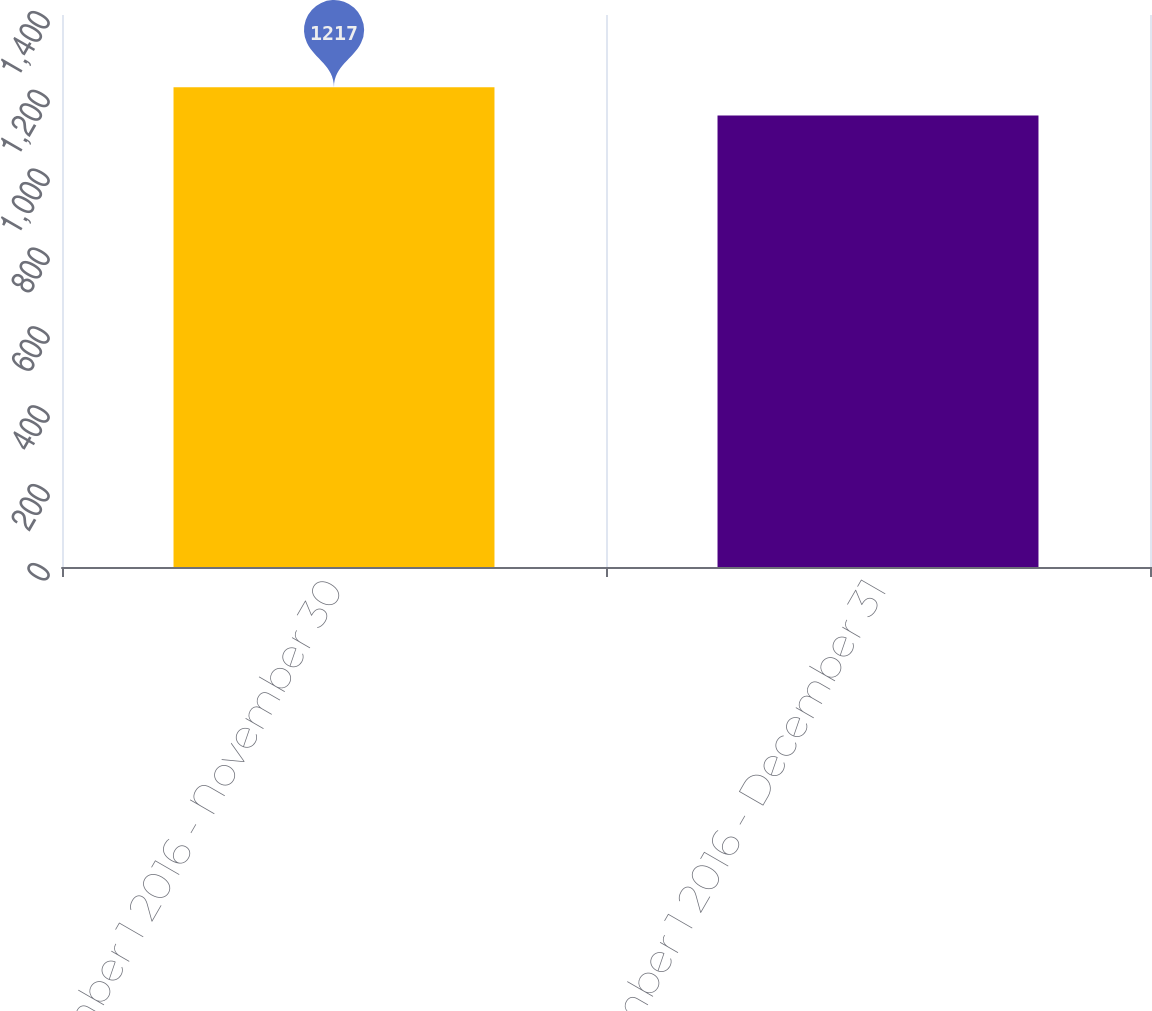Convert chart. <chart><loc_0><loc_0><loc_500><loc_500><bar_chart><fcel>November 1 2016 - November 30<fcel>December 1 2016 - December 31<nl><fcel>1217<fcel>1145<nl></chart> 